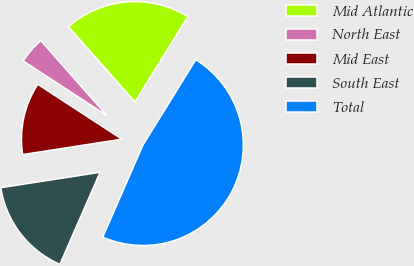Convert chart to OTSL. <chart><loc_0><loc_0><loc_500><loc_500><pie_chart><fcel>Mid Atlantic<fcel>North East<fcel>Mid East<fcel>South East<fcel>Total<nl><fcel>20.34%<fcel>4.28%<fcel>11.65%<fcel>16.0%<fcel>47.72%<nl></chart> 